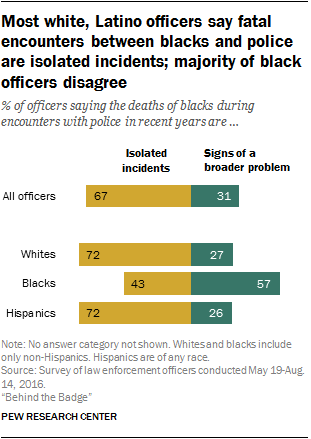Point out several critical features in this image. Isolated incidents are not a reflection of a broader problem, but rather a rare occurrence. According to a recent survey, only 0.02% of people responded that they had no answer to the question. 